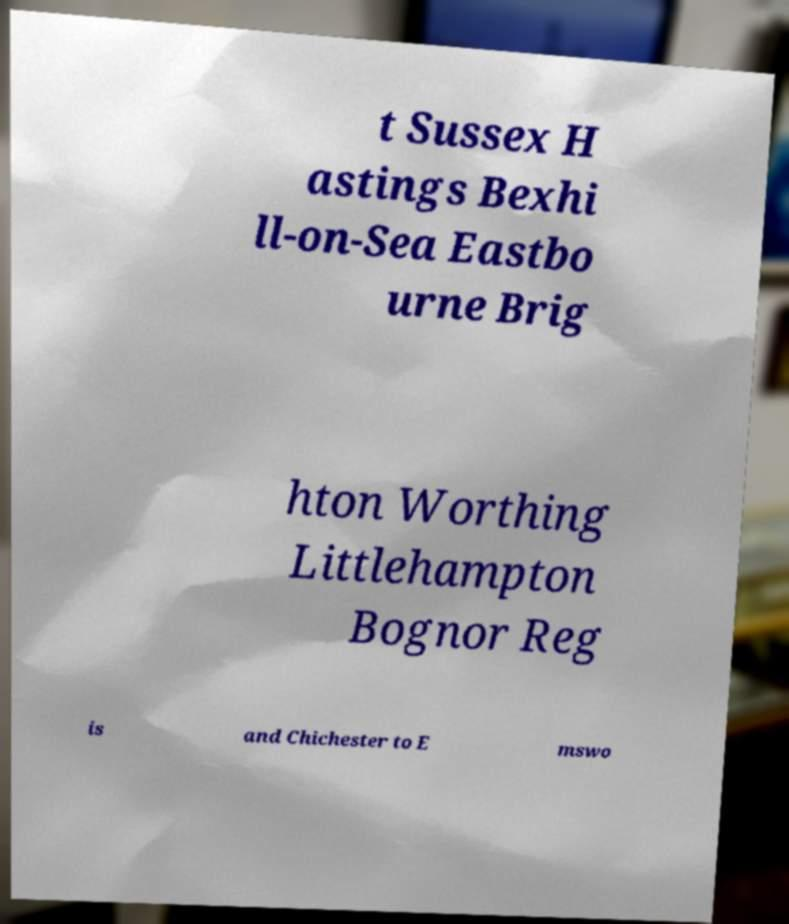Please identify and transcribe the text found in this image. t Sussex H astings Bexhi ll-on-Sea Eastbo urne Brig hton Worthing Littlehampton Bognor Reg is and Chichester to E mswo 